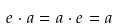<formula> <loc_0><loc_0><loc_500><loc_500>e \cdot a = a \cdot e = a</formula> 